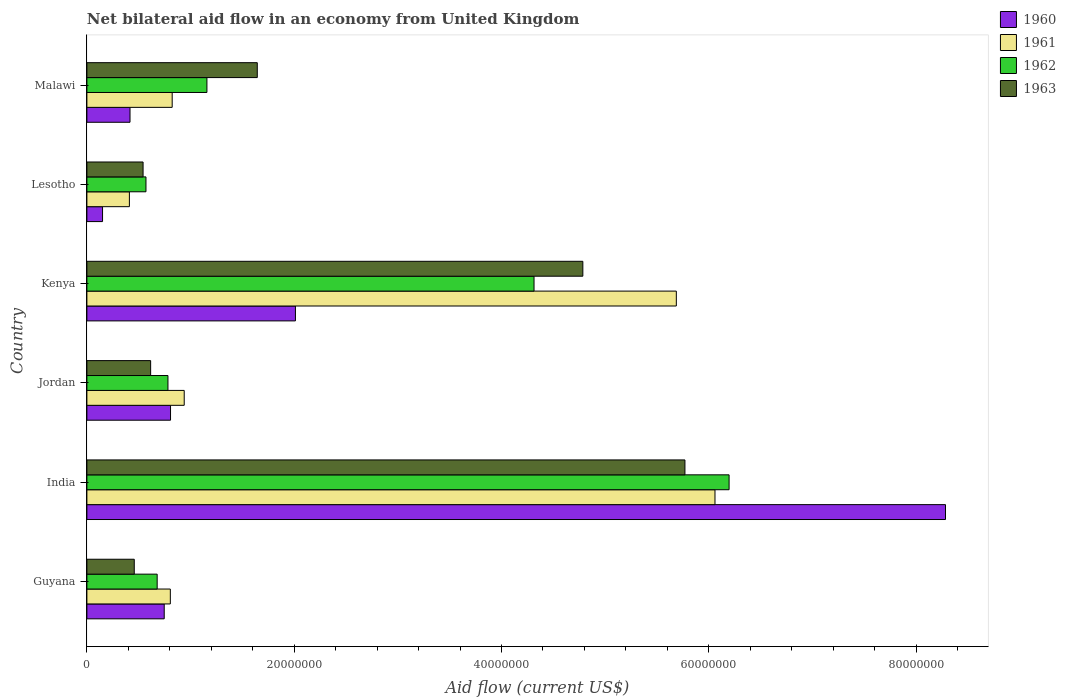What is the net bilateral aid flow in 1961 in Jordan?
Provide a short and direct response. 9.39e+06. Across all countries, what is the maximum net bilateral aid flow in 1963?
Provide a succinct answer. 5.77e+07. Across all countries, what is the minimum net bilateral aid flow in 1961?
Make the answer very short. 4.10e+06. In which country was the net bilateral aid flow in 1961 minimum?
Make the answer very short. Lesotho. What is the total net bilateral aid flow in 1962 in the graph?
Offer a very short reply. 1.37e+08. What is the difference between the net bilateral aid flow in 1960 in Guyana and that in Malawi?
Offer a terse response. 3.30e+06. What is the difference between the net bilateral aid flow in 1960 in Guyana and the net bilateral aid flow in 1963 in Lesotho?
Offer a terse response. 2.04e+06. What is the average net bilateral aid flow in 1960 per country?
Provide a short and direct response. 2.07e+07. What is the difference between the net bilateral aid flow in 1963 and net bilateral aid flow in 1961 in Jordan?
Keep it short and to the point. -3.24e+06. In how many countries, is the net bilateral aid flow in 1962 greater than 44000000 US$?
Offer a very short reply. 1. What is the ratio of the net bilateral aid flow in 1963 in Kenya to that in Malawi?
Offer a terse response. 2.91. Is the net bilateral aid flow in 1962 in Jordan less than that in Malawi?
Offer a terse response. Yes. What is the difference between the highest and the second highest net bilateral aid flow in 1961?
Make the answer very short. 3.73e+06. What is the difference between the highest and the lowest net bilateral aid flow in 1961?
Provide a short and direct response. 5.65e+07. Is the sum of the net bilateral aid flow in 1962 in India and Lesotho greater than the maximum net bilateral aid flow in 1961 across all countries?
Keep it short and to the point. Yes. What does the 1st bar from the top in Lesotho represents?
Make the answer very short. 1963. How many bars are there?
Ensure brevity in your answer.  24. How many countries are there in the graph?
Your answer should be compact. 6. Are the values on the major ticks of X-axis written in scientific E-notation?
Give a very brief answer. No. How are the legend labels stacked?
Provide a succinct answer. Vertical. What is the title of the graph?
Make the answer very short. Net bilateral aid flow in an economy from United Kingdom. Does "1981" appear as one of the legend labels in the graph?
Keep it short and to the point. No. What is the label or title of the X-axis?
Offer a terse response. Aid flow (current US$). What is the label or title of the Y-axis?
Give a very brief answer. Country. What is the Aid flow (current US$) of 1960 in Guyana?
Offer a terse response. 7.46e+06. What is the Aid flow (current US$) of 1961 in Guyana?
Provide a short and direct response. 8.05e+06. What is the Aid flow (current US$) of 1962 in Guyana?
Your answer should be compact. 6.78e+06. What is the Aid flow (current US$) in 1963 in Guyana?
Your response must be concise. 4.57e+06. What is the Aid flow (current US$) of 1960 in India?
Provide a succinct answer. 8.28e+07. What is the Aid flow (current US$) in 1961 in India?
Make the answer very short. 6.06e+07. What is the Aid flow (current US$) in 1962 in India?
Provide a succinct answer. 6.20e+07. What is the Aid flow (current US$) in 1963 in India?
Your answer should be compact. 5.77e+07. What is the Aid flow (current US$) in 1960 in Jordan?
Keep it short and to the point. 8.07e+06. What is the Aid flow (current US$) in 1961 in Jordan?
Offer a terse response. 9.39e+06. What is the Aid flow (current US$) in 1962 in Jordan?
Ensure brevity in your answer.  7.82e+06. What is the Aid flow (current US$) in 1963 in Jordan?
Your response must be concise. 6.15e+06. What is the Aid flow (current US$) of 1960 in Kenya?
Offer a very short reply. 2.01e+07. What is the Aid flow (current US$) of 1961 in Kenya?
Your response must be concise. 5.69e+07. What is the Aid flow (current US$) in 1962 in Kenya?
Offer a very short reply. 4.31e+07. What is the Aid flow (current US$) in 1963 in Kenya?
Your answer should be very brief. 4.78e+07. What is the Aid flow (current US$) of 1960 in Lesotho?
Provide a succinct answer. 1.51e+06. What is the Aid flow (current US$) in 1961 in Lesotho?
Offer a very short reply. 4.10e+06. What is the Aid flow (current US$) of 1962 in Lesotho?
Your response must be concise. 5.70e+06. What is the Aid flow (current US$) of 1963 in Lesotho?
Your answer should be compact. 5.42e+06. What is the Aid flow (current US$) of 1960 in Malawi?
Provide a succinct answer. 4.16e+06. What is the Aid flow (current US$) of 1961 in Malawi?
Your response must be concise. 8.23e+06. What is the Aid flow (current US$) of 1962 in Malawi?
Provide a short and direct response. 1.16e+07. What is the Aid flow (current US$) of 1963 in Malawi?
Provide a short and direct response. 1.64e+07. Across all countries, what is the maximum Aid flow (current US$) of 1960?
Provide a succinct answer. 8.28e+07. Across all countries, what is the maximum Aid flow (current US$) of 1961?
Give a very brief answer. 6.06e+07. Across all countries, what is the maximum Aid flow (current US$) of 1962?
Offer a very short reply. 6.20e+07. Across all countries, what is the maximum Aid flow (current US$) in 1963?
Your response must be concise. 5.77e+07. Across all countries, what is the minimum Aid flow (current US$) of 1960?
Keep it short and to the point. 1.51e+06. Across all countries, what is the minimum Aid flow (current US$) of 1961?
Provide a succinct answer. 4.10e+06. Across all countries, what is the minimum Aid flow (current US$) of 1962?
Make the answer very short. 5.70e+06. Across all countries, what is the minimum Aid flow (current US$) of 1963?
Offer a terse response. 4.57e+06. What is the total Aid flow (current US$) of 1960 in the graph?
Keep it short and to the point. 1.24e+08. What is the total Aid flow (current US$) of 1961 in the graph?
Your response must be concise. 1.47e+08. What is the total Aid flow (current US$) in 1962 in the graph?
Your response must be concise. 1.37e+08. What is the total Aid flow (current US$) of 1963 in the graph?
Make the answer very short. 1.38e+08. What is the difference between the Aid flow (current US$) of 1960 in Guyana and that in India?
Your answer should be very brief. -7.54e+07. What is the difference between the Aid flow (current US$) of 1961 in Guyana and that in India?
Ensure brevity in your answer.  -5.26e+07. What is the difference between the Aid flow (current US$) of 1962 in Guyana and that in India?
Keep it short and to the point. -5.52e+07. What is the difference between the Aid flow (current US$) of 1963 in Guyana and that in India?
Keep it short and to the point. -5.31e+07. What is the difference between the Aid flow (current US$) in 1960 in Guyana and that in Jordan?
Provide a succinct answer. -6.10e+05. What is the difference between the Aid flow (current US$) of 1961 in Guyana and that in Jordan?
Offer a very short reply. -1.34e+06. What is the difference between the Aid flow (current US$) of 1962 in Guyana and that in Jordan?
Keep it short and to the point. -1.04e+06. What is the difference between the Aid flow (current US$) of 1963 in Guyana and that in Jordan?
Offer a terse response. -1.58e+06. What is the difference between the Aid flow (current US$) of 1960 in Guyana and that in Kenya?
Your response must be concise. -1.27e+07. What is the difference between the Aid flow (current US$) of 1961 in Guyana and that in Kenya?
Provide a succinct answer. -4.88e+07. What is the difference between the Aid flow (current US$) of 1962 in Guyana and that in Kenya?
Offer a very short reply. -3.64e+07. What is the difference between the Aid flow (current US$) of 1963 in Guyana and that in Kenya?
Your response must be concise. -4.33e+07. What is the difference between the Aid flow (current US$) in 1960 in Guyana and that in Lesotho?
Provide a succinct answer. 5.95e+06. What is the difference between the Aid flow (current US$) in 1961 in Guyana and that in Lesotho?
Your response must be concise. 3.95e+06. What is the difference between the Aid flow (current US$) in 1962 in Guyana and that in Lesotho?
Make the answer very short. 1.08e+06. What is the difference between the Aid flow (current US$) of 1963 in Guyana and that in Lesotho?
Give a very brief answer. -8.50e+05. What is the difference between the Aid flow (current US$) of 1960 in Guyana and that in Malawi?
Your answer should be very brief. 3.30e+06. What is the difference between the Aid flow (current US$) in 1961 in Guyana and that in Malawi?
Provide a short and direct response. -1.80e+05. What is the difference between the Aid flow (current US$) of 1962 in Guyana and that in Malawi?
Ensure brevity in your answer.  -4.80e+06. What is the difference between the Aid flow (current US$) in 1963 in Guyana and that in Malawi?
Offer a terse response. -1.19e+07. What is the difference between the Aid flow (current US$) in 1960 in India and that in Jordan?
Ensure brevity in your answer.  7.48e+07. What is the difference between the Aid flow (current US$) in 1961 in India and that in Jordan?
Make the answer very short. 5.12e+07. What is the difference between the Aid flow (current US$) in 1962 in India and that in Jordan?
Make the answer very short. 5.41e+07. What is the difference between the Aid flow (current US$) in 1963 in India and that in Jordan?
Your answer should be compact. 5.16e+07. What is the difference between the Aid flow (current US$) of 1960 in India and that in Kenya?
Provide a succinct answer. 6.27e+07. What is the difference between the Aid flow (current US$) in 1961 in India and that in Kenya?
Offer a very short reply. 3.73e+06. What is the difference between the Aid flow (current US$) in 1962 in India and that in Kenya?
Your answer should be very brief. 1.88e+07. What is the difference between the Aid flow (current US$) in 1963 in India and that in Kenya?
Ensure brevity in your answer.  9.85e+06. What is the difference between the Aid flow (current US$) of 1960 in India and that in Lesotho?
Keep it short and to the point. 8.13e+07. What is the difference between the Aid flow (current US$) in 1961 in India and that in Lesotho?
Your response must be concise. 5.65e+07. What is the difference between the Aid flow (current US$) of 1962 in India and that in Lesotho?
Offer a terse response. 5.63e+07. What is the difference between the Aid flow (current US$) in 1963 in India and that in Lesotho?
Offer a very short reply. 5.23e+07. What is the difference between the Aid flow (current US$) of 1960 in India and that in Malawi?
Make the answer very short. 7.87e+07. What is the difference between the Aid flow (current US$) of 1961 in India and that in Malawi?
Your response must be concise. 5.24e+07. What is the difference between the Aid flow (current US$) in 1962 in India and that in Malawi?
Provide a succinct answer. 5.04e+07. What is the difference between the Aid flow (current US$) in 1963 in India and that in Malawi?
Your answer should be very brief. 4.13e+07. What is the difference between the Aid flow (current US$) in 1960 in Jordan and that in Kenya?
Offer a very short reply. -1.20e+07. What is the difference between the Aid flow (current US$) in 1961 in Jordan and that in Kenya?
Give a very brief answer. -4.75e+07. What is the difference between the Aid flow (current US$) in 1962 in Jordan and that in Kenya?
Provide a succinct answer. -3.53e+07. What is the difference between the Aid flow (current US$) of 1963 in Jordan and that in Kenya?
Keep it short and to the point. -4.17e+07. What is the difference between the Aid flow (current US$) in 1960 in Jordan and that in Lesotho?
Offer a very short reply. 6.56e+06. What is the difference between the Aid flow (current US$) of 1961 in Jordan and that in Lesotho?
Your response must be concise. 5.29e+06. What is the difference between the Aid flow (current US$) in 1962 in Jordan and that in Lesotho?
Provide a succinct answer. 2.12e+06. What is the difference between the Aid flow (current US$) in 1963 in Jordan and that in Lesotho?
Your response must be concise. 7.30e+05. What is the difference between the Aid flow (current US$) in 1960 in Jordan and that in Malawi?
Keep it short and to the point. 3.91e+06. What is the difference between the Aid flow (current US$) of 1961 in Jordan and that in Malawi?
Provide a succinct answer. 1.16e+06. What is the difference between the Aid flow (current US$) in 1962 in Jordan and that in Malawi?
Offer a terse response. -3.76e+06. What is the difference between the Aid flow (current US$) in 1963 in Jordan and that in Malawi?
Ensure brevity in your answer.  -1.03e+07. What is the difference between the Aid flow (current US$) of 1960 in Kenya and that in Lesotho?
Offer a terse response. 1.86e+07. What is the difference between the Aid flow (current US$) of 1961 in Kenya and that in Lesotho?
Keep it short and to the point. 5.28e+07. What is the difference between the Aid flow (current US$) of 1962 in Kenya and that in Lesotho?
Give a very brief answer. 3.74e+07. What is the difference between the Aid flow (current US$) of 1963 in Kenya and that in Lesotho?
Offer a very short reply. 4.24e+07. What is the difference between the Aid flow (current US$) in 1960 in Kenya and that in Malawi?
Your answer should be very brief. 1.60e+07. What is the difference between the Aid flow (current US$) of 1961 in Kenya and that in Malawi?
Your response must be concise. 4.86e+07. What is the difference between the Aid flow (current US$) in 1962 in Kenya and that in Malawi?
Your answer should be very brief. 3.16e+07. What is the difference between the Aid flow (current US$) of 1963 in Kenya and that in Malawi?
Give a very brief answer. 3.14e+07. What is the difference between the Aid flow (current US$) of 1960 in Lesotho and that in Malawi?
Provide a succinct answer. -2.65e+06. What is the difference between the Aid flow (current US$) of 1961 in Lesotho and that in Malawi?
Offer a very short reply. -4.13e+06. What is the difference between the Aid flow (current US$) in 1962 in Lesotho and that in Malawi?
Your answer should be very brief. -5.88e+06. What is the difference between the Aid flow (current US$) of 1963 in Lesotho and that in Malawi?
Offer a terse response. -1.10e+07. What is the difference between the Aid flow (current US$) of 1960 in Guyana and the Aid flow (current US$) of 1961 in India?
Your answer should be compact. -5.31e+07. What is the difference between the Aid flow (current US$) of 1960 in Guyana and the Aid flow (current US$) of 1962 in India?
Your response must be concise. -5.45e+07. What is the difference between the Aid flow (current US$) of 1960 in Guyana and the Aid flow (current US$) of 1963 in India?
Keep it short and to the point. -5.02e+07. What is the difference between the Aid flow (current US$) of 1961 in Guyana and the Aid flow (current US$) of 1962 in India?
Provide a short and direct response. -5.39e+07. What is the difference between the Aid flow (current US$) of 1961 in Guyana and the Aid flow (current US$) of 1963 in India?
Give a very brief answer. -4.96e+07. What is the difference between the Aid flow (current US$) in 1962 in Guyana and the Aid flow (current US$) in 1963 in India?
Provide a short and direct response. -5.09e+07. What is the difference between the Aid flow (current US$) of 1960 in Guyana and the Aid flow (current US$) of 1961 in Jordan?
Provide a succinct answer. -1.93e+06. What is the difference between the Aid flow (current US$) of 1960 in Guyana and the Aid flow (current US$) of 1962 in Jordan?
Ensure brevity in your answer.  -3.60e+05. What is the difference between the Aid flow (current US$) of 1960 in Guyana and the Aid flow (current US$) of 1963 in Jordan?
Give a very brief answer. 1.31e+06. What is the difference between the Aid flow (current US$) in 1961 in Guyana and the Aid flow (current US$) in 1962 in Jordan?
Provide a short and direct response. 2.30e+05. What is the difference between the Aid flow (current US$) of 1961 in Guyana and the Aid flow (current US$) of 1963 in Jordan?
Ensure brevity in your answer.  1.90e+06. What is the difference between the Aid flow (current US$) in 1962 in Guyana and the Aid flow (current US$) in 1963 in Jordan?
Your answer should be very brief. 6.30e+05. What is the difference between the Aid flow (current US$) in 1960 in Guyana and the Aid flow (current US$) in 1961 in Kenya?
Offer a terse response. -4.94e+07. What is the difference between the Aid flow (current US$) of 1960 in Guyana and the Aid flow (current US$) of 1962 in Kenya?
Your answer should be compact. -3.57e+07. What is the difference between the Aid flow (current US$) in 1960 in Guyana and the Aid flow (current US$) in 1963 in Kenya?
Make the answer very short. -4.04e+07. What is the difference between the Aid flow (current US$) in 1961 in Guyana and the Aid flow (current US$) in 1962 in Kenya?
Ensure brevity in your answer.  -3.51e+07. What is the difference between the Aid flow (current US$) of 1961 in Guyana and the Aid flow (current US$) of 1963 in Kenya?
Your answer should be compact. -3.98e+07. What is the difference between the Aid flow (current US$) in 1962 in Guyana and the Aid flow (current US$) in 1963 in Kenya?
Offer a very short reply. -4.11e+07. What is the difference between the Aid flow (current US$) of 1960 in Guyana and the Aid flow (current US$) of 1961 in Lesotho?
Offer a terse response. 3.36e+06. What is the difference between the Aid flow (current US$) of 1960 in Guyana and the Aid flow (current US$) of 1962 in Lesotho?
Keep it short and to the point. 1.76e+06. What is the difference between the Aid flow (current US$) of 1960 in Guyana and the Aid flow (current US$) of 1963 in Lesotho?
Keep it short and to the point. 2.04e+06. What is the difference between the Aid flow (current US$) in 1961 in Guyana and the Aid flow (current US$) in 1962 in Lesotho?
Your answer should be compact. 2.35e+06. What is the difference between the Aid flow (current US$) in 1961 in Guyana and the Aid flow (current US$) in 1963 in Lesotho?
Your response must be concise. 2.63e+06. What is the difference between the Aid flow (current US$) in 1962 in Guyana and the Aid flow (current US$) in 1963 in Lesotho?
Offer a very short reply. 1.36e+06. What is the difference between the Aid flow (current US$) in 1960 in Guyana and the Aid flow (current US$) in 1961 in Malawi?
Your answer should be very brief. -7.70e+05. What is the difference between the Aid flow (current US$) of 1960 in Guyana and the Aid flow (current US$) of 1962 in Malawi?
Give a very brief answer. -4.12e+06. What is the difference between the Aid flow (current US$) in 1960 in Guyana and the Aid flow (current US$) in 1963 in Malawi?
Your answer should be compact. -8.98e+06. What is the difference between the Aid flow (current US$) of 1961 in Guyana and the Aid flow (current US$) of 1962 in Malawi?
Your response must be concise. -3.53e+06. What is the difference between the Aid flow (current US$) in 1961 in Guyana and the Aid flow (current US$) in 1963 in Malawi?
Make the answer very short. -8.39e+06. What is the difference between the Aid flow (current US$) of 1962 in Guyana and the Aid flow (current US$) of 1963 in Malawi?
Offer a very short reply. -9.66e+06. What is the difference between the Aid flow (current US$) in 1960 in India and the Aid flow (current US$) in 1961 in Jordan?
Your answer should be very brief. 7.34e+07. What is the difference between the Aid flow (current US$) of 1960 in India and the Aid flow (current US$) of 1962 in Jordan?
Provide a short and direct response. 7.50e+07. What is the difference between the Aid flow (current US$) in 1960 in India and the Aid flow (current US$) in 1963 in Jordan?
Keep it short and to the point. 7.67e+07. What is the difference between the Aid flow (current US$) of 1961 in India and the Aid flow (current US$) of 1962 in Jordan?
Make the answer very short. 5.28e+07. What is the difference between the Aid flow (current US$) in 1961 in India and the Aid flow (current US$) in 1963 in Jordan?
Offer a very short reply. 5.44e+07. What is the difference between the Aid flow (current US$) of 1962 in India and the Aid flow (current US$) of 1963 in Jordan?
Provide a succinct answer. 5.58e+07. What is the difference between the Aid flow (current US$) of 1960 in India and the Aid flow (current US$) of 1961 in Kenya?
Offer a terse response. 2.60e+07. What is the difference between the Aid flow (current US$) in 1960 in India and the Aid flow (current US$) in 1962 in Kenya?
Provide a succinct answer. 3.97e+07. What is the difference between the Aid flow (current US$) in 1960 in India and the Aid flow (current US$) in 1963 in Kenya?
Your response must be concise. 3.50e+07. What is the difference between the Aid flow (current US$) of 1961 in India and the Aid flow (current US$) of 1962 in Kenya?
Provide a succinct answer. 1.75e+07. What is the difference between the Aid flow (current US$) of 1961 in India and the Aid flow (current US$) of 1963 in Kenya?
Offer a very short reply. 1.28e+07. What is the difference between the Aid flow (current US$) in 1962 in India and the Aid flow (current US$) in 1963 in Kenya?
Keep it short and to the point. 1.41e+07. What is the difference between the Aid flow (current US$) of 1960 in India and the Aid flow (current US$) of 1961 in Lesotho?
Make the answer very short. 7.87e+07. What is the difference between the Aid flow (current US$) of 1960 in India and the Aid flow (current US$) of 1962 in Lesotho?
Your response must be concise. 7.71e+07. What is the difference between the Aid flow (current US$) of 1960 in India and the Aid flow (current US$) of 1963 in Lesotho?
Give a very brief answer. 7.74e+07. What is the difference between the Aid flow (current US$) of 1961 in India and the Aid flow (current US$) of 1962 in Lesotho?
Your answer should be very brief. 5.49e+07. What is the difference between the Aid flow (current US$) of 1961 in India and the Aid flow (current US$) of 1963 in Lesotho?
Offer a very short reply. 5.52e+07. What is the difference between the Aid flow (current US$) of 1962 in India and the Aid flow (current US$) of 1963 in Lesotho?
Offer a terse response. 5.65e+07. What is the difference between the Aid flow (current US$) in 1960 in India and the Aid flow (current US$) in 1961 in Malawi?
Provide a succinct answer. 7.46e+07. What is the difference between the Aid flow (current US$) of 1960 in India and the Aid flow (current US$) of 1962 in Malawi?
Provide a succinct answer. 7.13e+07. What is the difference between the Aid flow (current US$) in 1960 in India and the Aid flow (current US$) in 1963 in Malawi?
Ensure brevity in your answer.  6.64e+07. What is the difference between the Aid flow (current US$) in 1961 in India and the Aid flow (current US$) in 1962 in Malawi?
Make the answer very short. 4.90e+07. What is the difference between the Aid flow (current US$) of 1961 in India and the Aid flow (current US$) of 1963 in Malawi?
Give a very brief answer. 4.42e+07. What is the difference between the Aid flow (current US$) in 1962 in India and the Aid flow (current US$) in 1963 in Malawi?
Provide a short and direct response. 4.55e+07. What is the difference between the Aid flow (current US$) of 1960 in Jordan and the Aid flow (current US$) of 1961 in Kenya?
Your response must be concise. -4.88e+07. What is the difference between the Aid flow (current US$) of 1960 in Jordan and the Aid flow (current US$) of 1962 in Kenya?
Ensure brevity in your answer.  -3.51e+07. What is the difference between the Aid flow (current US$) in 1960 in Jordan and the Aid flow (current US$) in 1963 in Kenya?
Your answer should be very brief. -3.98e+07. What is the difference between the Aid flow (current US$) in 1961 in Jordan and the Aid flow (current US$) in 1962 in Kenya?
Provide a short and direct response. -3.38e+07. What is the difference between the Aid flow (current US$) in 1961 in Jordan and the Aid flow (current US$) in 1963 in Kenya?
Make the answer very short. -3.85e+07. What is the difference between the Aid flow (current US$) in 1962 in Jordan and the Aid flow (current US$) in 1963 in Kenya?
Offer a terse response. -4.00e+07. What is the difference between the Aid flow (current US$) of 1960 in Jordan and the Aid flow (current US$) of 1961 in Lesotho?
Make the answer very short. 3.97e+06. What is the difference between the Aid flow (current US$) of 1960 in Jordan and the Aid flow (current US$) of 1962 in Lesotho?
Provide a short and direct response. 2.37e+06. What is the difference between the Aid flow (current US$) of 1960 in Jordan and the Aid flow (current US$) of 1963 in Lesotho?
Keep it short and to the point. 2.65e+06. What is the difference between the Aid flow (current US$) of 1961 in Jordan and the Aid flow (current US$) of 1962 in Lesotho?
Your answer should be very brief. 3.69e+06. What is the difference between the Aid flow (current US$) of 1961 in Jordan and the Aid flow (current US$) of 1963 in Lesotho?
Your answer should be compact. 3.97e+06. What is the difference between the Aid flow (current US$) in 1962 in Jordan and the Aid flow (current US$) in 1963 in Lesotho?
Offer a very short reply. 2.40e+06. What is the difference between the Aid flow (current US$) of 1960 in Jordan and the Aid flow (current US$) of 1962 in Malawi?
Keep it short and to the point. -3.51e+06. What is the difference between the Aid flow (current US$) of 1960 in Jordan and the Aid flow (current US$) of 1963 in Malawi?
Make the answer very short. -8.37e+06. What is the difference between the Aid flow (current US$) in 1961 in Jordan and the Aid flow (current US$) in 1962 in Malawi?
Keep it short and to the point. -2.19e+06. What is the difference between the Aid flow (current US$) in 1961 in Jordan and the Aid flow (current US$) in 1963 in Malawi?
Ensure brevity in your answer.  -7.05e+06. What is the difference between the Aid flow (current US$) in 1962 in Jordan and the Aid flow (current US$) in 1963 in Malawi?
Keep it short and to the point. -8.62e+06. What is the difference between the Aid flow (current US$) of 1960 in Kenya and the Aid flow (current US$) of 1961 in Lesotho?
Your response must be concise. 1.60e+07. What is the difference between the Aid flow (current US$) of 1960 in Kenya and the Aid flow (current US$) of 1962 in Lesotho?
Give a very brief answer. 1.44e+07. What is the difference between the Aid flow (current US$) in 1960 in Kenya and the Aid flow (current US$) in 1963 in Lesotho?
Offer a terse response. 1.47e+07. What is the difference between the Aid flow (current US$) of 1961 in Kenya and the Aid flow (current US$) of 1962 in Lesotho?
Your answer should be very brief. 5.12e+07. What is the difference between the Aid flow (current US$) of 1961 in Kenya and the Aid flow (current US$) of 1963 in Lesotho?
Offer a terse response. 5.14e+07. What is the difference between the Aid flow (current US$) of 1962 in Kenya and the Aid flow (current US$) of 1963 in Lesotho?
Give a very brief answer. 3.77e+07. What is the difference between the Aid flow (current US$) of 1960 in Kenya and the Aid flow (current US$) of 1961 in Malawi?
Ensure brevity in your answer.  1.19e+07. What is the difference between the Aid flow (current US$) of 1960 in Kenya and the Aid flow (current US$) of 1962 in Malawi?
Give a very brief answer. 8.54e+06. What is the difference between the Aid flow (current US$) of 1960 in Kenya and the Aid flow (current US$) of 1963 in Malawi?
Your answer should be compact. 3.68e+06. What is the difference between the Aid flow (current US$) in 1961 in Kenya and the Aid flow (current US$) in 1962 in Malawi?
Provide a succinct answer. 4.53e+07. What is the difference between the Aid flow (current US$) of 1961 in Kenya and the Aid flow (current US$) of 1963 in Malawi?
Your answer should be very brief. 4.04e+07. What is the difference between the Aid flow (current US$) in 1962 in Kenya and the Aid flow (current US$) in 1963 in Malawi?
Offer a terse response. 2.67e+07. What is the difference between the Aid flow (current US$) in 1960 in Lesotho and the Aid flow (current US$) in 1961 in Malawi?
Your response must be concise. -6.72e+06. What is the difference between the Aid flow (current US$) of 1960 in Lesotho and the Aid flow (current US$) of 1962 in Malawi?
Keep it short and to the point. -1.01e+07. What is the difference between the Aid flow (current US$) of 1960 in Lesotho and the Aid flow (current US$) of 1963 in Malawi?
Your response must be concise. -1.49e+07. What is the difference between the Aid flow (current US$) in 1961 in Lesotho and the Aid flow (current US$) in 1962 in Malawi?
Offer a very short reply. -7.48e+06. What is the difference between the Aid flow (current US$) of 1961 in Lesotho and the Aid flow (current US$) of 1963 in Malawi?
Your answer should be very brief. -1.23e+07. What is the difference between the Aid flow (current US$) in 1962 in Lesotho and the Aid flow (current US$) in 1963 in Malawi?
Offer a terse response. -1.07e+07. What is the average Aid flow (current US$) in 1960 per country?
Make the answer very short. 2.07e+07. What is the average Aid flow (current US$) in 1961 per country?
Ensure brevity in your answer.  2.45e+07. What is the average Aid flow (current US$) of 1962 per country?
Your answer should be compact. 2.28e+07. What is the average Aid flow (current US$) in 1963 per country?
Make the answer very short. 2.30e+07. What is the difference between the Aid flow (current US$) in 1960 and Aid flow (current US$) in 1961 in Guyana?
Offer a very short reply. -5.90e+05. What is the difference between the Aid flow (current US$) in 1960 and Aid flow (current US$) in 1962 in Guyana?
Give a very brief answer. 6.80e+05. What is the difference between the Aid flow (current US$) of 1960 and Aid flow (current US$) of 1963 in Guyana?
Provide a short and direct response. 2.89e+06. What is the difference between the Aid flow (current US$) in 1961 and Aid flow (current US$) in 1962 in Guyana?
Make the answer very short. 1.27e+06. What is the difference between the Aid flow (current US$) of 1961 and Aid flow (current US$) of 1963 in Guyana?
Your answer should be compact. 3.48e+06. What is the difference between the Aid flow (current US$) in 1962 and Aid flow (current US$) in 1963 in Guyana?
Your response must be concise. 2.21e+06. What is the difference between the Aid flow (current US$) in 1960 and Aid flow (current US$) in 1961 in India?
Provide a succinct answer. 2.22e+07. What is the difference between the Aid flow (current US$) of 1960 and Aid flow (current US$) of 1962 in India?
Your answer should be very brief. 2.09e+07. What is the difference between the Aid flow (current US$) in 1960 and Aid flow (current US$) in 1963 in India?
Make the answer very short. 2.51e+07. What is the difference between the Aid flow (current US$) of 1961 and Aid flow (current US$) of 1962 in India?
Your answer should be compact. -1.36e+06. What is the difference between the Aid flow (current US$) of 1961 and Aid flow (current US$) of 1963 in India?
Your response must be concise. 2.90e+06. What is the difference between the Aid flow (current US$) of 1962 and Aid flow (current US$) of 1963 in India?
Offer a very short reply. 4.26e+06. What is the difference between the Aid flow (current US$) of 1960 and Aid flow (current US$) of 1961 in Jordan?
Make the answer very short. -1.32e+06. What is the difference between the Aid flow (current US$) in 1960 and Aid flow (current US$) in 1963 in Jordan?
Make the answer very short. 1.92e+06. What is the difference between the Aid flow (current US$) of 1961 and Aid flow (current US$) of 1962 in Jordan?
Your answer should be compact. 1.57e+06. What is the difference between the Aid flow (current US$) in 1961 and Aid flow (current US$) in 1963 in Jordan?
Your answer should be very brief. 3.24e+06. What is the difference between the Aid flow (current US$) of 1962 and Aid flow (current US$) of 1963 in Jordan?
Your answer should be compact. 1.67e+06. What is the difference between the Aid flow (current US$) of 1960 and Aid flow (current US$) of 1961 in Kenya?
Offer a very short reply. -3.68e+07. What is the difference between the Aid flow (current US$) in 1960 and Aid flow (current US$) in 1962 in Kenya?
Your answer should be compact. -2.30e+07. What is the difference between the Aid flow (current US$) of 1960 and Aid flow (current US$) of 1963 in Kenya?
Your response must be concise. -2.77e+07. What is the difference between the Aid flow (current US$) in 1961 and Aid flow (current US$) in 1962 in Kenya?
Provide a short and direct response. 1.37e+07. What is the difference between the Aid flow (current US$) in 1961 and Aid flow (current US$) in 1963 in Kenya?
Your response must be concise. 9.02e+06. What is the difference between the Aid flow (current US$) in 1962 and Aid flow (current US$) in 1963 in Kenya?
Your answer should be very brief. -4.71e+06. What is the difference between the Aid flow (current US$) in 1960 and Aid flow (current US$) in 1961 in Lesotho?
Provide a succinct answer. -2.59e+06. What is the difference between the Aid flow (current US$) of 1960 and Aid flow (current US$) of 1962 in Lesotho?
Provide a short and direct response. -4.19e+06. What is the difference between the Aid flow (current US$) in 1960 and Aid flow (current US$) in 1963 in Lesotho?
Your answer should be very brief. -3.91e+06. What is the difference between the Aid flow (current US$) of 1961 and Aid flow (current US$) of 1962 in Lesotho?
Ensure brevity in your answer.  -1.60e+06. What is the difference between the Aid flow (current US$) in 1961 and Aid flow (current US$) in 1963 in Lesotho?
Offer a terse response. -1.32e+06. What is the difference between the Aid flow (current US$) in 1962 and Aid flow (current US$) in 1963 in Lesotho?
Your response must be concise. 2.80e+05. What is the difference between the Aid flow (current US$) of 1960 and Aid flow (current US$) of 1961 in Malawi?
Keep it short and to the point. -4.07e+06. What is the difference between the Aid flow (current US$) in 1960 and Aid flow (current US$) in 1962 in Malawi?
Ensure brevity in your answer.  -7.42e+06. What is the difference between the Aid flow (current US$) of 1960 and Aid flow (current US$) of 1963 in Malawi?
Your answer should be very brief. -1.23e+07. What is the difference between the Aid flow (current US$) of 1961 and Aid flow (current US$) of 1962 in Malawi?
Offer a terse response. -3.35e+06. What is the difference between the Aid flow (current US$) in 1961 and Aid flow (current US$) in 1963 in Malawi?
Give a very brief answer. -8.21e+06. What is the difference between the Aid flow (current US$) in 1962 and Aid flow (current US$) in 1963 in Malawi?
Your answer should be very brief. -4.86e+06. What is the ratio of the Aid flow (current US$) in 1960 in Guyana to that in India?
Your response must be concise. 0.09. What is the ratio of the Aid flow (current US$) of 1961 in Guyana to that in India?
Your response must be concise. 0.13. What is the ratio of the Aid flow (current US$) of 1962 in Guyana to that in India?
Provide a short and direct response. 0.11. What is the ratio of the Aid flow (current US$) of 1963 in Guyana to that in India?
Make the answer very short. 0.08. What is the ratio of the Aid flow (current US$) of 1960 in Guyana to that in Jordan?
Provide a succinct answer. 0.92. What is the ratio of the Aid flow (current US$) of 1961 in Guyana to that in Jordan?
Provide a succinct answer. 0.86. What is the ratio of the Aid flow (current US$) of 1962 in Guyana to that in Jordan?
Keep it short and to the point. 0.87. What is the ratio of the Aid flow (current US$) of 1963 in Guyana to that in Jordan?
Ensure brevity in your answer.  0.74. What is the ratio of the Aid flow (current US$) of 1960 in Guyana to that in Kenya?
Keep it short and to the point. 0.37. What is the ratio of the Aid flow (current US$) of 1961 in Guyana to that in Kenya?
Offer a terse response. 0.14. What is the ratio of the Aid flow (current US$) in 1962 in Guyana to that in Kenya?
Make the answer very short. 0.16. What is the ratio of the Aid flow (current US$) in 1963 in Guyana to that in Kenya?
Your answer should be very brief. 0.1. What is the ratio of the Aid flow (current US$) of 1960 in Guyana to that in Lesotho?
Your answer should be compact. 4.94. What is the ratio of the Aid flow (current US$) in 1961 in Guyana to that in Lesotho?
Ensure brevity in your answer.  1.96. What is the ratio of the Aid flow (current US$) of 1962 in Guyana to that in Lesotho?
Ensure brevity in your answer.  1.19. What is the ratio of the Aid flow (current US$) of 1963 in Guyana to that in Lesotho?
Offer a terse response. 0.84. What is the ratio of the Aid flow (current US$) of 1960 in Guyana to that in Malawi?
Your answer should be compact. 1.79. What is the ratio of the Aid flow (current US$) of 1961 in Guyana to that in Malawi?
Your answer should be very brief. 0.98. What is the ratio of the Aid flow (current US$) in 1962 in Guyana to that in Malawi?
Make the answer very short. 0.59. What is the ratio of the Aid flow (current US$) in 1963 in Guyana to that in Malawi?
Your response must be concise. 0.28. What is the ratio of the Aid flow (current US$) of 1960 in India to that in Jordan?
Your answer should be very brief. 10.27. What is the ratio of the Aid flow (current US$) of 1961 in India to that in Jordan?
Your response must be concise. 6.45. What is the ratio of the Aid flow (current US$) of 1962 in India to that in Jordan?
Provide a succinct answer. 7.92. What is the ratio of the Aid flow (current US$) of 1963 in India to that in Jordan?
Give a very brief answer. 9.38. What is the ratio of the Aid flow (current US$) in 1960 in India to that in Kenya?
Offer a terse response. 4.12. What is the ratio of the Aid flow (current US$) of 1961 in India to that in Kenya?
Your answer should be very brief. 1.07. What is the ratio of the Aid flow (current US$) in 1962 in India to that in Kenya?
Provide a succinct answer. 1.44. What is the ratio of the Aid flow (current US$) of 1963 in India to that in Kenya?
Provide a succinct answer. 1.21. What is the ratio of the Aid flow (current US$) in 1960 in India to that in Lesotho?
Keep it short and to the point. 54.86. What is the ratio of the Aid flow (current US$) of 1961 in India to that in Lesotho?
Provide a succinct answer. 14.78. What is the ratio of the Aid flow (current US$) of 1962 in India to that in Lesotho?
Make the answer very short. 10.87. What is the ratio of the Aid flow (current US$) in 1963 in India to that in Lesotho?
Make the answer very short. 10.65. What is the ratio of the Aid flow (current US$) in 1960 in India to that in Malawi?
Provide a short and direct response. 19.91. What is the ratio of the Aid flow (current US$) in 1961 in India to that in Malawi?
Make the answer very short. 7.36. What is the ratio of the Aid flow (current US$) of 1962 in India to that in Malawi?
Give a very brief answer. 5.35. What is the ratio of the Aid flow (current US$) of 1963 in India to that in Malawi?
Your answer should be very brief. 3.51. What is the ratio of the Aid flow (current US$) of 1960 in Jordan to that in Kenya?
Your answer should be very brief. 0.4. What is the ratio of the Aid flow (current US$) in 1961 in Jordan to that in Kenya?
Make the answer very short. 0.17. What is the ratio of the Aid flow (current US$) of 1962 in Jordan to that in Kenya?
Provide a short and direct response. 0.18. What is the ratio of the Aid flow (current US$) in 1963 in Jordan to that in Kenya?
Provide a succinct answer. 0.13. What is the ratio of the Aid flow (current US$) of 1960 in Jordan to that in Lesotho?
Make the answer very short. 5.34. What is the ratio of the Aid flow (current US$) of 1961 in Jordan to that in Lesotho?
Provide a short and direct response. 2.29. What is the ratio of the Aid flow (current US$) of 1962 in Jordan to that in Lesotho?
Your response must be concise. 1.37. What is the ratio of the Aid flow (current US$) in 1963 in Jordan to that in Lesotho?
Provide a short and direct response. 1.13. What is the ratio of the Aid flow (current US$) in 1960 in Jordan to that in Malawi?
Your response must be concise. 1.94. What is the ratio of the Aid flow (current US$) in 1961 in Jordan to that in Malawi?
Your answer should be compact. 1.14. What is the ratio of the Aid flow (current US$) in 1962 in Jordan to that in Malawi?
Offer a terse response. 0.68. What is the ratio of the Aid flow (current US$) of 1963 in Jordan to that in Malawi?
Provide a short and direct response. 0.37. What is the ratio of the Aid flow (current US$) of 1960 in Kenya to that in Lesotho?
Provide a succinct answer. 13.32. What is the ratio of the Aid flow (current US$) of 1961 in Kenya to that in Lesotho?
Offer a very short reply. 13.87. What is the ratio of the Aid flow (current US$) in 1962 in Kenya to that in Lesotho?
Make the answer very short. 7.57. What is the ratio of the Aid flow (current US$) in 1963 in Kenya to that in Lesotho?
Provide a succinct answer. 8.83. What is the ratio of the Aid flow (current US$) of 1960 in Kenya to that in Malawi?
Ensure brevity in your answer.  4.84. What is the ratio of the Aid flow (current US$) of 1961 in Kenya to that in Malawi?
Your answer should be compact. 6.91. What is the ratio of the Aid flow (current US$) of 1962 in Kenya to that in Malawi?
Your answer should be compact. 3.73. What is the ratio of the Aid flow (current US$) of 1963 in Kenya to that in Malawi?
Your response must be concise. 2.91. What is the ratio of the Aid flow (current US$) of 1960 in Lesotho to that in Malawi?
Make the answer very short. 0.36. What is the ratio of the Aid flow (current US$) in 1961 in Lesotho to that in Malawi?
Your answer should be very brief. 0.5. What is the ratio of the Aid flow (current US$) of 1962 in Lesotho to that in Malawi?
Provide a succinct answer. 0.49. What is the ratio of the Aid flow (current US$) of 1963 in Lesotho to that in Malawi?
Provide a succinct answer. 0.33. What is the difference between the highest and the second highest Aid flow (current US$) of 1960?
Ensure brevity in your answer.  6.27e+07. What is the difference between the highest and the second highest Aid flow (current US$) in 1961?
Ensure brevity in your answer.  3.73e+06. What is the difference between the highest and the second highest Aid flow (current US$) in 1962?
Make the answer very short. 1.88e+07. What is the difference between the highest and the second highest Aid flow (current US$) of 1963?
Offer a very short reply. 9.85e+06. What is the difference between the highest and the lowest Aid flow (current US$) of 1960?
Ensure brevity in your answer.  8.13e+07. What is the difference between the highest and the lowest Aid flow (current US$) in 1961?
Make the answer very short. 5.65e+07. What is the difference between the highest and the lowest Aid flow (current US$) in 1962?
Give a very brief answer. 5.63e+07. What is the difference between the highest and the lowest Aid flow (current US$) of 1963?
Make the answer very short. 5.31e+07. 